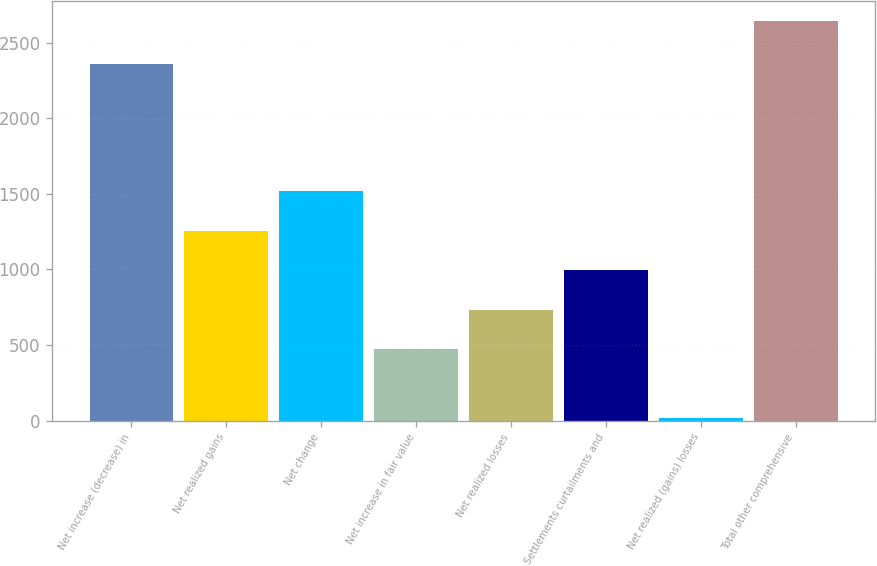Convert chart to OTSL. <chart><loc_0><loc_0><loc_500><loc_500><bar_chart><fcel>Net increase (decrease) in<fcel>Net realized gains<fcel>Net change<fcel>Net increase in fair value<fcel>Net realized losses<fcel>Settlements curtailments and<fcel>Net realized (gains) losses<fcel>Total other comprehensive<nl><fcel>2357<fcel>1257<fcel>1519<fcel>471<fcel>733<fcel>995<fcel>20<fcel>2640<nl></chart> 